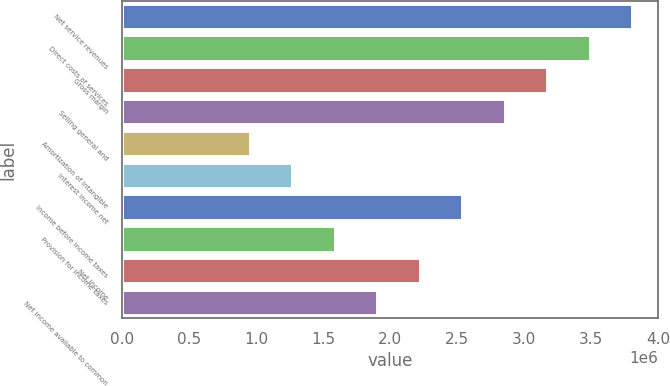<chart> <loc_0><loc_0><loc_500><loc_500><bar_chart><fcel>Net service revenues<fcel>Direct costs of services<fcel>Gross margin<fcel>Selling general and<fcel>Amortization of intangible<fcel>Interest income net<fcel>Income before income taxes<fcel>Provision for income taxes<fcel>Net income<fcel>Net income available to common<nl><fcel>3.81011e+06<fcel>3.4926e+06<fcel>3.17509e+06<fcel>2.85758e+06<fcel>952528<fcel>1.27004e+06<fcel>2.54007e+06<fcel>1.58755e+06<fcel>2.22257e+06<fcel>1.90506e+06<nl></chart> 